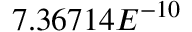Convert formula to latex. <formula><loc_0><loc_0><loc_500><loc_500>7 . 3 6 7 1 4 E ^ { - 1 0 }</formula> 